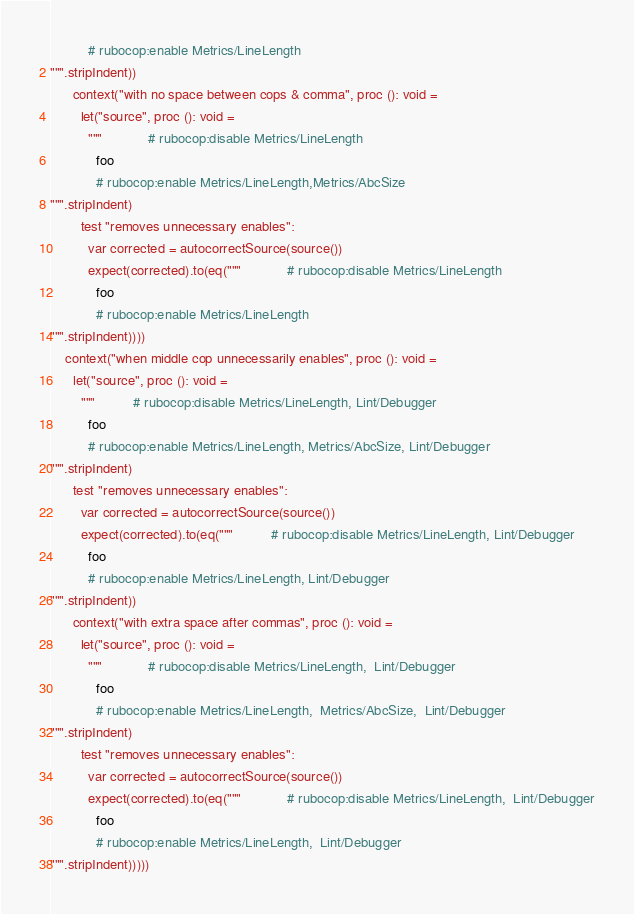Convert code to text. <code><loc_0><loc_0><loc_500><loc_500><_Nim_>          # rubocop:enable Metrics/LineLength
""".stripIndent))
      context("with no space between cops & comma", proc (): void =
        let("source", proc (): void =
          """            # rubocop:disable Metrics/LineLength
            foo
            # rubocop:enable Metrics/LineLength,Metrics/AbcSize
""".stripIndent)
        test "removes unnecessary enables":
          var corrected = autocorrectSource(source())
          expect(corrected).to(eq("""            # rubocop:disable Metrics/LineLength
            foo
            # rubocop:enable Metrics/LineLength
""".stripIndent))))
    context("when middle cop unnecessarily enables", proc (): void =
      let("source", proc (): void =
        """          # rubocop:disable Metrics/LineLength, Lint/Debugger
          foo
          # rubocop:enable Metrics/LineLength, Metrics/AbcSize, Lint/Debugger
""".stripIndent)
      test "removes unnecessary enables":
        var corrected = autocorrectSource(source())
        expect(corrected).to(eq("""          # rubocop:disable Metrics/LineLength, Lint/Debugger
          foo
          # rubocop:enable Metrics/LineLength, Lint/Debugger
""".stripIndent))
      context("with extra space after commas", proc (): void =
        let("source", proc (): void =
          """            # rubocop:disable Metrics/LineLength,  Lint/Debugger
            foo
            # rubocop:enable Metrics/LineLength,  Metrics/AbcSize,  Lint/Debugger
""".stripIndent)
        test "removes unnecessary enables":
          var corrected = autocorrectSource(source())
          expect(corrected).to(eq("""            # rubocop:disable Metrics/LineLength,  Lint/Debugger
            foo
            # rubocop:enable Metrics/LineLength,  Lint/Debugger
""".stripIndent)))))
</code> 